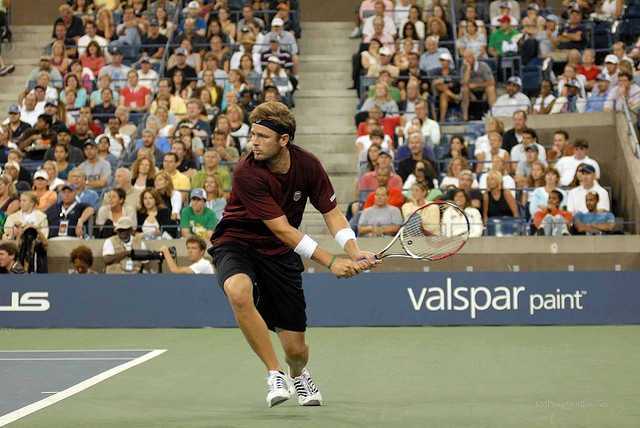Describe the objects in this image and their specific colors. I can see people in tan, black, and gray tones, people in tan, black, maroon, and darkgray tones, tennis racket in tan, darkgray, and beige tones, people in tan, darkgray, and gray tones, and people in tan, gray, and maroon tones in this image. 